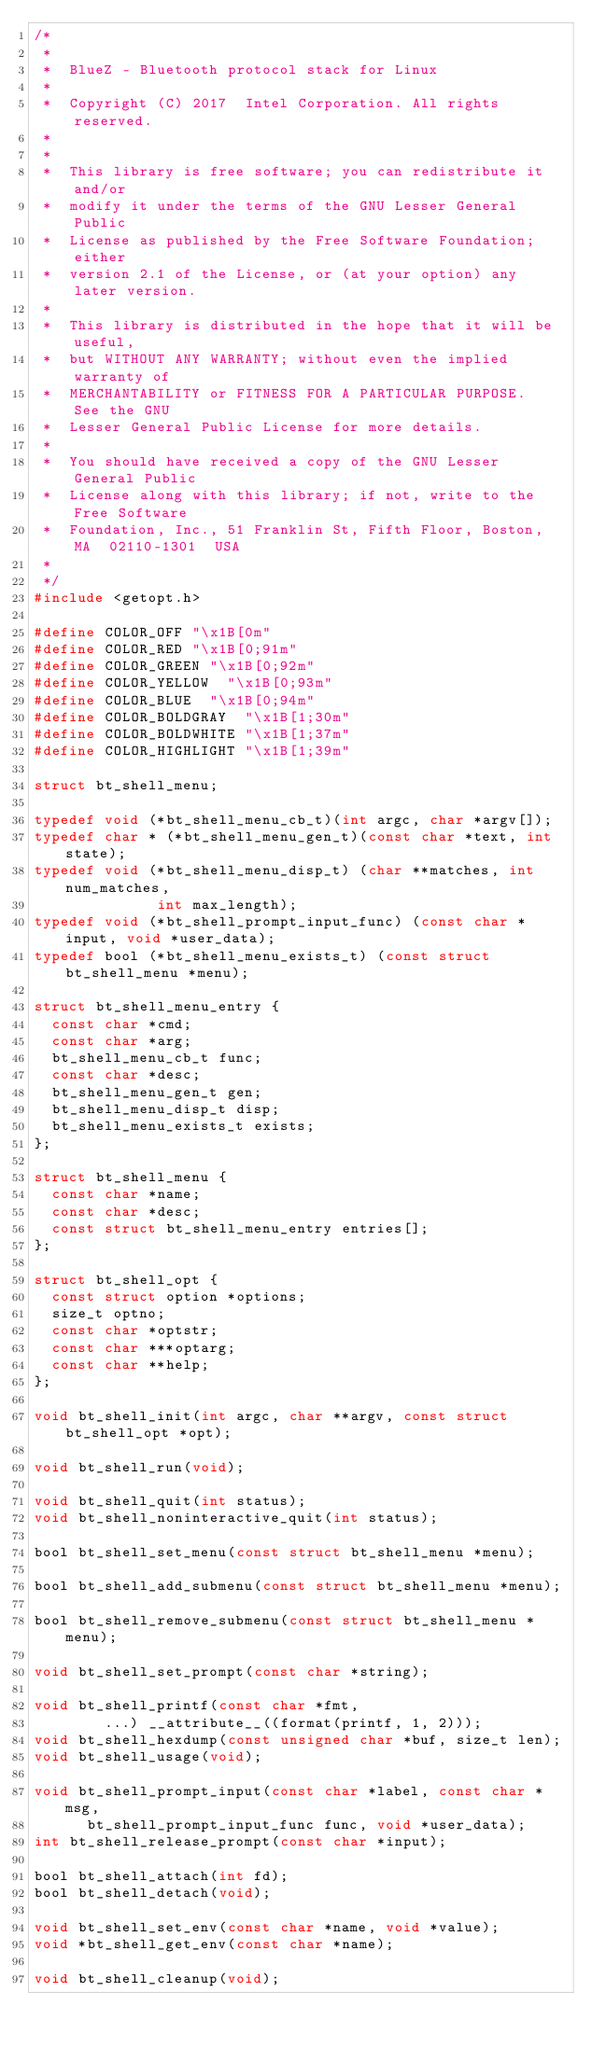Convert code to text. <code><loc_0><loc_0><loc_500><loc_500><_C_>/*
 *
 *  BlueZ - Bluetooth protocol stack for Linux
 *
 *  Copyright (C) 2017  Intel Corporation. All rights reserved.
 *
 *
 *  This library is free software; you can redistribute it and/or
 *  modify it under the terms of the GNU Lesser General Public
 *  License as published by the Free Software Foundation; either
 *  version 2.1 of the License, or (at your option) any later version.
 *
 *  This library is distributed in the hope that it will be useful,
 *  but WITHOUT ANY WARRANTY; without even the implied warranty of
 *  MERCHANTABILITY or FITNESS FOR A PARTICULAR PURPOSE.  See the GNU
 *  Lesser General Public License for more details.
 *
 *  You should have received a copy of the GNU Lesser General Public
 *  License along with this library; if not, write to the Free Software
 *  Foundation, Inc., 51 Franklin St, Fifth Floor, Boston, MA  02110-1301  USA
 *
 */
#include <getopt.h>

#define COLOR_OFF	"\x1B[0m"
#define COLOR_RED	"\x1B[0;91m"
#define COLOR_GREEN	"\x1B[0;92m"
#define COLOR_YELLOW	"\x1B[0;93m"
#define COLOR_BLUE	"\x1B[0;94m"
#define COLOR_BOLDGRAY	"\x1B[1;30m"
#define COLOR_BOLDWHITE	"\x1B[1;37m"
#define COLOR_HIGHLIGHT	"\x1B[1;39m"

struct bt_shell_menu;

typedef void (*bt_shell_menu_cb_t)(int argc, char *argv[]);
typedef char * (*bt_shell_menu_gen_t)(const char *text, int state);
typedef void (*bt_shell_menu_disp_t) (char **matches, int num_matches,
							int max_length);
typedef void (*bt_shell_prompt_input_func) (const char *input, void *user_data);
typedef bool (*bt_shell_menu_exists_t) (const struct bt_shell_menu *menu);

struct bt_shell_menu_entry {
	const char *cmd;
	const char *arg;
	bt_shell_menu_cb_t func;
	const char *desc;
	bt_shell_menu_gen_t gen;
	bt_shell_menu_disp_t disp;
	bt_shell_menu_exists_t exists;
};

struct bt_shell_menu {
	const char *name;
	const char *desc;
	const struct bt_shell_menu_entry entries[];
};

struct bt_shell_opt {
	const struct option *options;
	size_t optno;
	const char *optstr;
	const char ***optarg;
	const char **help;
};

void bt_shell_init(int argc, char **argv, const struct bt_shell_opt *opt);

void bt_shell_run(void);

void bt_shell_quit(int status);
void bt_shell_noninteractive_quit(int status);

bool bt_shell_set_menu(const struct bt_shell_menu *menu);

bool bt_shell_add_submenu(const struct bt_shell_menu *menu);

bool bt_shell_remove_submenu(const struct bt_shell_menu *menu);

void bt_shell_set_prompt(const char *string);

void bt_shell_printf(const char *fmt,
				...) __attribute__((format(printf, 1, 2)));
void bt_shell_hexdump(const unsigned char *buf, size_t len);
void bt_shell_usage(void);

void bt_shell_prompt_input(const char *label, const char *msg,
			bt_shell_prompt_input_func func, void *user_data);
int bt_shell_release_prompt(const char *input);

bool bt_shell_attach(int fd);
bool bt_shell_detach(void);

void bt_shell_set_env(const char *name, void *value);
void *bt_shell_get_env(const char *name);

void bt_shell_cleanup(void);
</code> 